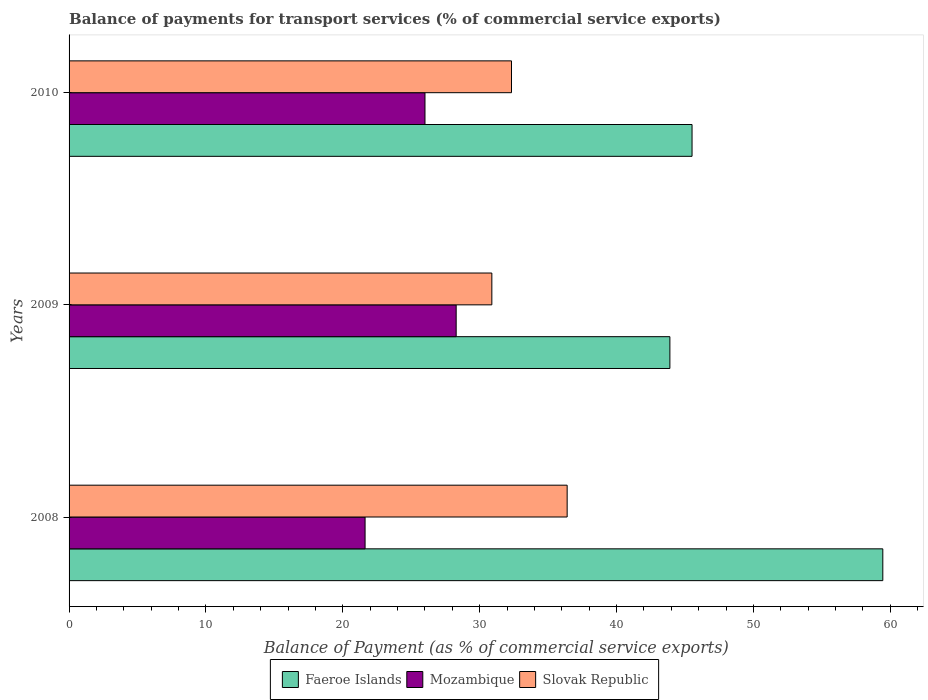How many groups of bars are there?
Provide a short and direct response. 3. Are the number of bars per tick equal to the number of legend labels?
Offer a very short reply. Yes. How many bars are there on the 2nd tick from the bottom?
Give a very brief answer. 3. What is the label of the 3rd group of bars from the top?
Give a very brief answer. 2008. In how many cases, is the number of bars for a given year not equal to the number of legend labels?
Keep it short and to the point. 0. What is the balance of payments for transport services in Mozambique in 2010?
Provide a succinct answer. 26.01. Across all years, what is the maximum balance of payments for transport services in Slovak Republic?
Give a very brief answer. 36.39. Across all years, what is the minimum balance of payments for transport services in Slovak Republic?
Make the answer very short. 30.89. In which year was the balance of payments for transport services in Mozambique minimum?
Make the answer very short. 2008. What is the total balance of payments for transport services in Faeroe Islands in the graph?
Offer a very short reply. 148.88. What is the difference between the balance of payments for transport services in Slovak Republic in 2009 and that in 2010?
Keep it short and to the point. -1.44. What is the difference between the balance of payments for transport services in Mozambique in 2009 and the balance of payments for transport services in Slovak Republic in 2008?
Offer a very short reply. -8.11. What is the average balance of payments for transport services in Mozambique per year?
Offer a terse response. 25.31. In the year 2010, what is the difference between the balance of payments for transport services in Slovak Republic and balance of payments for transport services in Faeroe Islands?
Keep it short and to the point. -13.19. What is the ratio of the balance of payments for transport services in Slovak Republic in 2008 to that in 2009?
Provide a short and direct response. 1.18. Is the balance of payments for transport services in Faeroe Islands in 2008 less than that in 2010?
Your answer should be very brief. No. What is the difference between the highest and the second highest balance of payments for transport services in Slovak Republic?
Provide a short and direct response. 4.07. What is the difference between the highest and the lowest balance of payments for transport services in Slovak Republic?
Ensure brevity in your answer.  5.5. In how many years, is the balance of payments for transport services in Faeroe Islands greater than the average balance of payments for transport services in Faeroe Islands taken over all years?
Your answer should be very brief. 1. What does the 1st bar from the top in 2010 represents?
Your answer should be compact. Slovak Republic. What does the 2nd bar from the bottom in 2010 represents?
Offer a terse response. Mozambique. Are all the bars in the graph horizontal?
Give a very brief answer. Yes. What is the difference between two consecutive major ticks on the X-axis?
Offer a terse response. 10. Are the values on the major ticks of X-axis written in scientific E-notation?
Give a very brief answer. No. How many legend labels are there?
Offer a terse response. 3. What is the title of the graph?
Your response must be concise. Balance of payments for transport services (% of commercial service exports). What is the label or title of the X-axis?
Give a very brief answer. Balance of Payment (as % of commercial service exports). What is the label or title of the Y-axis?
Offer a very short reply. Years. What is the Balance of Payment (as % of commercial service exports) in Faeroe Islands in 2008?
Make the answer very short. 59.46. What is the Balance of Payment (as % of commercial service exports) of Mozambique in 2008?
Keep it short and to the point. 21.63. What is the Balance of Payment (as % of commercial service exports) in Slovak Republic in 2008?
Provide a short and direct response. 36.39. What is the Balance of Payment (as % of commercial service exports) of Faeroe Islands in 2009?
Your answer should be very brief. 43.9. What is the Balance of Payment (as % of commercial service exports) of Mozambique in 2009?
Provide a short and direct response. 28.28. What is the Balance of Payment (as % of commercial service exports) in Slovak Republic in 2009?
Your response must be concise. 30.89. What is the Balance of Payment (as % of commercial service exports) of Faeroe Islands in 2010?
Your answer should be compact. 45.52. What is the Balance of Payment (as % of commercial service exports) of Mozambique in 2010?
Keep it short and to the point. 26.01. What is the Balance of Payment (as % of commercial service exports) of Slovak Republic in 2010?
Your answer should be very brief. 32.33. Across all years, what is the maximum Balance of Payment (as % of commercial service exports) in Faeroe Islands?
Offer a very short reply. 59.46. Across all years, what is the maximum Balance of Payment (as % of commercial service exports) of Mozambique?
Keep it short and to the point. 28.28. Across all years, what is the maximum Balance of Payment (as % of commercial service exports) of Slovak Republic?
Keep it short and to the point. 36.39. Across all years, what is the minimum Balance of Payment (as % of commercial service exports) of Faeroe Islands?
Provide a succinct answer. 43.9. Across all years, what is the minimum Balance of Payment (as % of commercial service exports) of Mozambique?
Keep it short and to the point. 21.63. Across all years, what is the minimum Balance of Payment (as % of commercial service exports) in Slovak Republic?
Keep it short and to the point. 30.89. What is the total Balance of Payment (as % of commercial service exports) of Faeroe Islands in the graph?
Provide a short and direct response. 148.88. What is the total Balance of Payment (as % of commercial service exports) in Mozambique in the graph?
Your response must be concise. 75.92. What is the total Balance of Payment (as % of commercial service exports) in Slovak Republic in the graph?
Give a very brief answer. 99.61. What is the difference between the Balance of Payment (as % of commercial service exports) in Faeroe Islands in 2008 and that in 2009?
Your response must be concise. 15.56. What is the difference between the Balance of Payment (as % of commercial service exports) in Mozambique in 2008 and that in 2009?
Your answer should be very brief. -6.66. What is the difference between the Balance of Payment (as % of commercial service exports) of Slovak Republic in 2008 and that in 2009?
Your answer should be very brief. 5.5. What is the difference between the Balance of Payment (as % of commercial service exports) in Faeroe Islands in 2008 and that in 2010?
Your answer should be very brief. 13.94. What is the difference between the Balance of Payment (as % of commercial service exports) of Mozambique in 2008 and that in 2010?
Provide a succinct answer. -4.38. What is the difference between the Balance of Payment (as % of commercial service exports) in Slovak Republic in 2008 and that in 2010?
Give a very brief answer. 4.07. What is the difference between the Balance of Payment (as % of commercial service exports) of Faeroe Islands in 2009 and that in 2010?
Offer a terse response. -1.62. What is the difference between the Balance of Payment (as % of commercial service exports) in Mozambique in 2009 and that in 2010?
Give a very brief answer. 2.28. What is the difference between the Balance of Payment (as % of commercial service exports) in Slovak Republic in 2009 and that in 2010?
Your response must be concise. -1.44. What is the difference between the Balance of Payment (as % of commercial service exports) in Faeroe Islands in 2008 and the Balance of Payment (as % of commercial service exports) in Mozambique in 2009?
Offer a terse response. 31.17. What is the difference between the Balance of Payment (as % of commercial service exports) in Faeroe Islands in 2008 and the Balance of Payment (as % of commercial service exports) in Slovak Republic in 2009?
Provide a succinct answer. 28.57. What is the difference between the Balance of Payment (as % of commercial service exports) of Mozambique in 2008 and the Balance of Payment (as % of commercial service exports) of Slovak Republic in 2009?
Ensure brevity in your answer.  -9.26. What is the difference between the Balance of Payment (as % of commercial service exports) of Faeroe Islands in 2008 and the Balance of Payment (as % of commercial service exports) of Mozambique in 2010?
Your response must be concise. 33.45. What is the difference between the Balance of Payment (as % of commercial service exports) of Faeroe Islands in 2008 and the Balance of Payment (as % of commercial service exports) of Slovak Republic in 2010?
Keep it short and to the point. 27.13. What is the difference between the Balance of Payment (as % of commercial service exports) of Mozambique in 2008 and the Balance of Payment (as % of commercial service exports) of Slovak Republic in 2010?
Keep it short and to the point. -10.7. What is the difference between the Balance of Payment (as % of commercial service exports) in Faeroe Islands in 2009 and the Balance of Payment (as % of commercial service exports) in Mozambique in 2010?
Your response must be concise. 17.9. What is the difference between the Balance of Payment (as % of commercial service exports) in Faeroe Islands in 2009 and the Balance of Payment (as % of commercial service exports) in Slovak Republic in 2010?
Ensure brevity in your answer.  11.57. What is the difference between the Balance of Payment (as % of commercial service exports) of Mozambique in 2009 and the Balance of Payment (as % of commercial service exports) of Slovak Republic in 2010?
Provide a succinct answer. -4.04. What is the average Balance of Payment (as % of commercial service exports) in Faeroe Islands per year?
Offer a terse response. 49.63. What is the average Balance of Payment (as % of commercial service exports) of Mozambique per year?
Give a very brief answer. 25.31. What is the average Balance of Payment (as % of commercial service exports) of Slovak Republic per year?
Your answer should be very brief. 33.2. In the year 2008, what is the difference between the Balance of Payment (as % of commercial service exports) of Faeroe Islands and Balance of Payment (as % of commercial service exports) of Mozambique?
Make the answer very short. 37.83. In the year 2008, what is the difference between the Balance of Payment (as % of commercial service exports) in Faeroe Islands and Balance of Payment (as % of commercial service exports) in Slovak Republic?
Your response must be concise. 23.06. In the year 2008, what is the difference between the Balance of Payment (as % of commercial service exports) of Mozambique and Balance of Payment (as % of commercial service exports) of Slovak Republic?
Make the answer very short. -14.77. In the year 2009, what is the difference between the Balance of Payment (as % of commercial service exports) of Faeroe Islands and Balance of Payment (as % of commercial service exports) of Mozambique?
Your response must be concise. 15.62. In the year 2009, what is the difference between the Balance of Payment (as % of commercial service exports) of Faeroe Islands and Balance of Payment (as % of commercial service exports) of Slovak Republic?
Your response must be concise. 13.01. In the year 2009, what is the difference between the Balance of Payment (as % of commercial service exports) of Mozambique and Balance of Payment (as % of commercial service exports) of Slovak Republic?
Offer a terse response. -2.61. In the year 2010, what is the difference between the Balance of Payment (as % of commercial service exports) in Faeroe Islands and Balance of Payment (as % of commercial service exports) in Mozambique?
Your answer should be compact. 19.51. In the year 2010, what is the difference between the Balance of Payment (as % of commercial service exports) in Faeroe Islands and Balance of Payment (as % of commercial service exports) in Slovak Republic?
Your answer should be compact. 13.19. In the year 2010, what is the difference between the Balance of Payment (as % of commercial service exports) of Mozambique and Balance of Payment (as % of commercial service exports) of Slovak Republic?
Your response must be concise. -6.32. What is the ratio of the Balance of Payment (as % of commercial service exports) in Faeroe Islands in 2008 to that in 2009?
Offer a terse response. 1.35. What is the ratio of the Balance of Payment (as % of commercial service exports) in Mozambique in 2008 to that in 2009?
Ensure brevity in your answer.  0.76. What is the ratio of the Balance of Payment (as % of commercial service exports) in Slovak Republic in 2008 to that in 2009?
Offer a very short reply. 1.18. What is the ratio of the Balance of Payment (as % of commercial service exports) of Faeroe Islands in 2008 to that in 2010?
Offer a terse response. 1.31. What is the ratio of the Balance of Payment (as % of commercial service exports) of Mozambique in 2008 to that in 2010?
Your response must be concise. 0.83. What is the ratio of the Balance of Payment (as % of commercial service exports) of Slovak Republic in 2008 to that in 2010?
Offer a terse response. 1.13. What is the ratio of the Balance of Payment (as % of commercial service exports) in Faeroe Islands in 2009 to that in 2010?
Provide a short and direct response. 0.96. What is the ratio of the Balance of Payment (as % of commercial service exports) of Mozambique in 2009 to that in 2010?
Provide a succinct answer. 1.09. What is the ratio of the Balance of Payment (as % of commercial service exports) in Slovak Republic in 2009 to that in 2010?
Offer a very short reply. 0.96. What is the difference between the highest and the second highest Balance of Payment (as % of commercial service exports) of Faeroe Islands?
Your response must be concise. 13.94. What is the difference between the highest and the second highest Balance of Payment (as % of commercial service exports) in Mozambique?
Ensure brevity in your answer.  2.28. What is the difference between the highest and the second highest Balance of Payment (as % of commercial service exports) of Slovak Republic?
Make the answer very short. 4.07. What is the difference between the highest and the lowest Balance of Payment (as % of commercial service exports) of Faeroe Islands?
Provide a succinct answer. 15.56. What is the difference between the highest and the lowest Balance of Payment (as % of commercial service exports) in Mozambique?
Provide a succinct answer. 6.66. What is the difference between the highest and the lowest Balance of Payment (as % of commercial service exports) in Slovak Republic?
Offer a terse response. 5.5. 